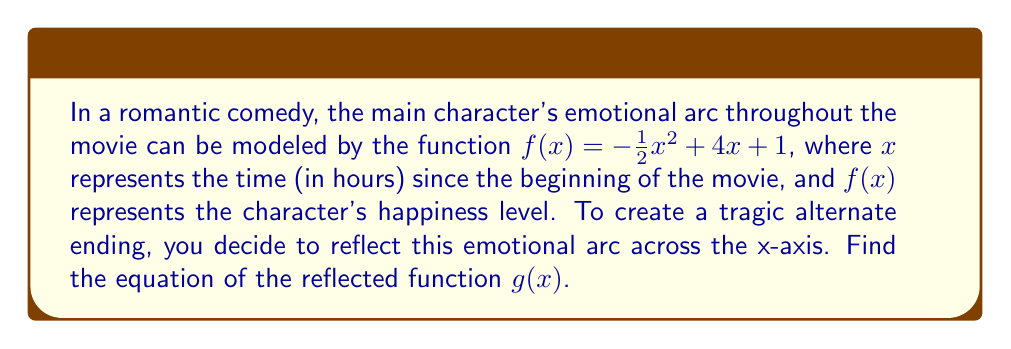Teach me how to tackle this problem. To reflect a function across the x-axis, we multiply the entire function by -1. This process inverts the graph vertically, effectively flipping it upside down.

Given function: $f(x) = -\frac{1}{2}x^2 + 4x + 1$

Steps to reflect across the x-axis:
1. Multiply the entire function by -1:
   $g(x) = -1 \cdot (-\frac{1}{2}x^2 + 4x + 1)$

2. Distribute the negative sign:
   $g(x) = \frac{1}{2}x^2 - 4x - 1$

The resulting function $g(x)$ represents the reflected emotional arc, where positive happiness values become negative and vice versa. This creates a "mirror image" of the original arc across the x-axis, suitable for a tragic alternate ending to the romantic comedy.
Answer: $g(x) = \frac{1}{2}x^2 - 4x - 1$ 